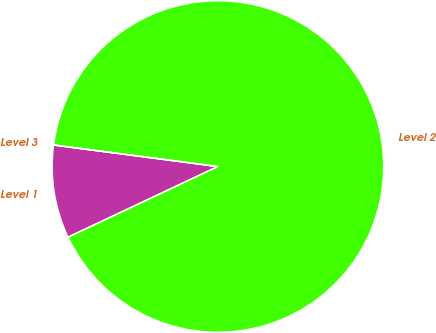Convert chart to OTSL. <chart><loc_0><loc_0><loc_500><loc_500><pie_chart><fcel>Level 1<fcel>Level 2<fcel>Level 3<nl><fcel>9.09%<fcel>90.91%<fcel>0.0%<nl></chart> 